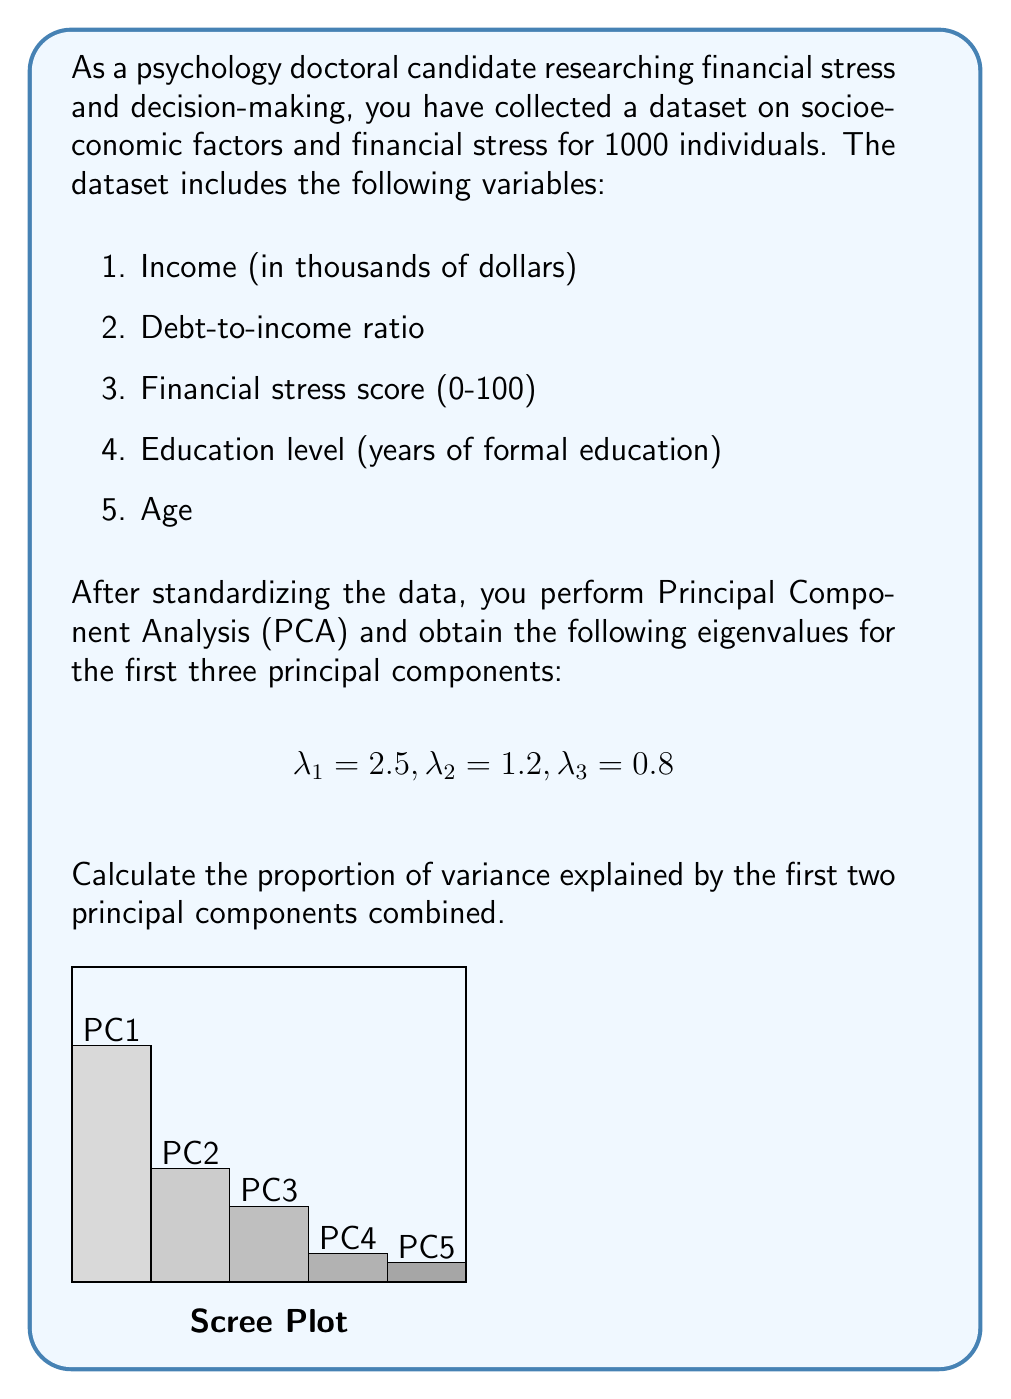Provide a solution to this math problem. To solve this problem, we'll follow these steps:

1. Understand what the eigenvalues represent in PCA.
2. Calculate the total variance in the dataset.
3. Calculate the proportion of variance explained by the first two principal components.

Step 1: In PCA, eigenvalues represent the amount of variance explained by each principal component. The larger the eigenvalue, the more variance is explained by that component.

Step 2: To calculate the total variance, we sum all the eigenvalues. In this case, we're given the first three, but since we standardized the data, we know that the total variance equals the number of variables (5 in this case). So:

Total variance = 5

Step 3: To calculate the proportion of variance explained by the first two principal components:

a) Sum the eigenvalues of the first two components:
   $\lambda_1 + \lambda_2 = 2.5 + 1.2 = 3.7$

b) Divide this sum by the total variance:
   Proportion = $\frac{3.7}{5} = 0.74$

c) Convert to percentage:
   0.74 * 100 = 74%

Therefore, the first two principal components combined explain 74% of the total variance in the dataset.
Answer: 74% 